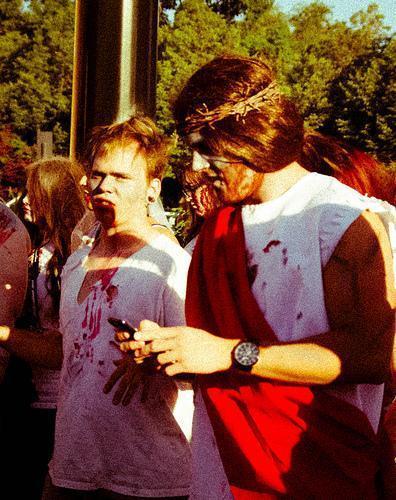How many people are looking at a phone?
Give a very brief answer. 1. 